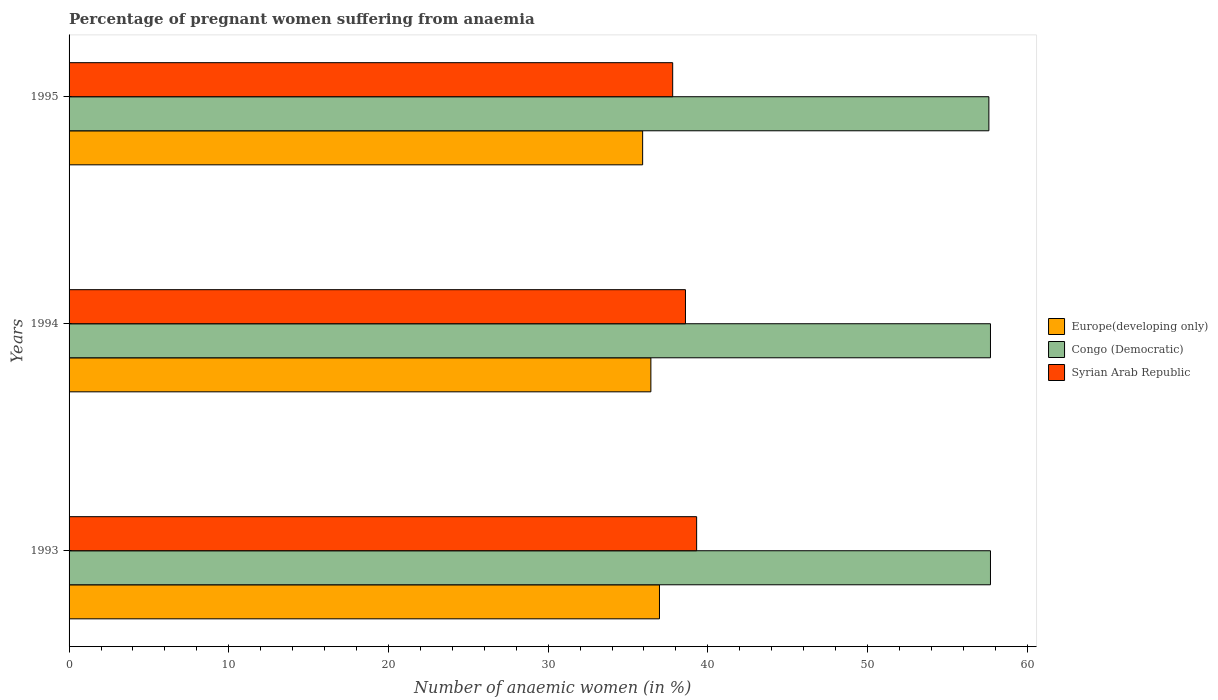What is the number of anaemic women in Congo (Democratic) in 1995?
Your answer should be compact. 57.6. Across all years, what is the maximum number of anaemic women in Syrian Arab Republic?
Provide a short and direct response. 39.3. Across all years, what is the minimum number of anaemic women in Congo (Democratic)?
Make the answer very short. 57.6. What is the total number of anaemic women in Congo (Democratic) in the graph?
Your answer should be very brief. 173. What is the difference between the number of anaemic women in Syrian Arab Republic in 1993 and that in 1995?
Provide a succinct answer. 1.5. What is the difference between the number of anaemic women in Europe(developing only) in 1993 and the number of anaemic women in Congo (Democratic) in 1995?
Keep it short and to the point. -20.63. What is the average number of anaemic women in Europe(developing only) per year?
Provide a succinct answer. 36.44. In the year 1993, what is the difference between the number of anaemic women in Congo (Democratic) and number of anaemic women in Europe(developing only)?
Ensure brevity in your answer.  20.73. What is the ratio of the number of anaemic women in Congo (Democratic) in 1993 to that in 1994?
Your answer should be compact. 1. Is the number of anaemic women in Syrian Arab Republic in 1994 less than that in 1995?
Ensure brevity in your answer.  No. What is the difference between the highest and the second highest number of anaemic women in Europe(developing only)?
Provide a short and direct response. 0.54. What is the difference between the highest and the lowest number of anaemic women in Europe(developing only)?
Your response must be concise. 1.05. Is the sum of the number of anaemic women in Congo (Democratic) in 1993 and 1994 greater than the maximum number of anaemic women in Syrian Arab Republic across all years?
Your answer should be very brief. Yes. What does the 1st bar from the top in 1995 represents?
Offer a very short reply. Syrian Arab Republic. What does the 1st bar from the bottom in 1995 represents?
Provide a short and direct response. Europe(developing only). Is it the case that in every year, the sum of the number of anaemic women in Europe(developing only) and number of anaemic women in Congo (Democratic) is greater than the number of anaemic women in Syrian Arab Republic?
Provide a succinct answer. Yes. What is the difference between two consecutive major ticks on the X-axis?
Provide a short and direct response. 10. Are the values on the major ticks of X-axis written in scientific E-notation?
Make the answer very short. No. Does the graph contain any zero values?
Provide a short and direct response. No. How many legend labels are there?
Give a very brief answer. 3. How are the legend labels stacked?
Offer a very short reply. Vertical. What is the title of the graph?
Keep it short and to the point. Percentage of pregnant women suffering from anaemia. Does "Ecuador" appear as one of the legend labels in the graph?
Make the answer very short. No. What is the label or title of the X-axis?
Make the answer very short. Number of anaemic women (in %). What is the label or title of the Y-axis?
Your answer should be compact. Years. What is the Number of anaemic women (in %) of Europe(developing only) in 1993?
Offer a very short reply. 36.97. What is the Number of anaemic women (in %) in Congo (Democratic) in 1993?
Provide a short and direct response. 57.7. What is the Number of anaemic women (in %) of Syrian Arab Republic in 1993?
Offer a very short reply. 39.3. What is the Number of anaemic women (in %) in Europe(developing only) in 1994?
Your answer should be very brief. 36.43. What is the Number of anaemic women (in %) of Congo (Democratic) in 1994?
Give a very brief answer. 57.7. What is the Number of anaemic women (in %) of Syrian Arab Republic in 1994?
Offer a very short reply. 38.6. What is the Number of anaemic women (in %) in Europe(developing only) in 1995?
Make the answer very short. 35.92. What is the Number of anaemic women (in %) of Congo (Democratic) in 1995?
Offer a very short reply. 57.6. What is the Number of anaemic women (in %) in Syrian Arab Republic in 1995?
Your answer should be very brief. 37.8. Across all years, what is the maximum Number of anaemic women (in %) in Europe(developing only)?
Keep it short and to the point. 36.97. Across all years, what is the maximum Number of anaemic women (in %) in Congo (Democratic)?
Give a very brief answer. 57.7. Across all years, what is the maximum Number of anaemic women (in %) in Syrian Arab Republic?
Your answer should be compact. 39.3. Across all years, what is the minimum Number of anaemic women (in %) of Europe(developing only)?
Provide a short and direct response. 35.92. Across all years, what is the minimum Number of anaemic women (in %) in Congo (Democratic)?
Provide a succinct answer. 57.6. Across all years, what is the minimum Number of anaemic women (in %) in Syrian Arab Republic?
Your answer should be compact. 37.8. What is the total Number of anaemic women (in %) in Europe(developing only) in the graph?
Offer a terse response. 109.32. What is the total Number of anaemic women (in %) in Congo (Democratic) in the graph?
Your response must be concise. 173. What is the total Number of anaemic women (in %) of Syrian Arab Republic in the graph?
Provide a short and direct response. 115.7. What is the difference between the Number of anaemic women (in %) in Europe(developing only) in 1993 and that in 1994?
Your answer should be very brief. 0.54. What is the difference between the Number of anaemic women (in %) in Europe(developing only) in 1993 and that in 1995?
Offer a terse response. 1.05. What is the difference between the Number of anaemic women (in %) of Congo (Democratic) in 1993 and that in 1995?
Offer a terse response. 0.1. What is the difference between the Number of anaemic women (in %) in Syrian Arab Republic in 1993 and that in 1995?
Offer a very short reply. 1.5. What is the difference between the Number of anaemic women (in %) of Europe(developing only) in 1994 and that in 1995?
Keep it short and to the point. 0.52. What is the difference between the Number of anaemic women (in %) in Europe(developing only) in 1993 and the Number of anaemic women (in %) in Congo (Democratic) in 1994?
Ensure brevity in your answer.  -20.73. What is the difference between the Number of anaemic women (in %) of Europe(developing only) in 1993 and the Number of anaemic women (in %) of Syrian Arab Republic in 1994?
Offer a terse response. -1.63. What is the difference between the Number of anaemic women (in %) in Congo (Democratic) in 1993 and the Number of anaemic women (in %) in Syrian Arab Republic in 1994?
Provide a short and direct response. 19.1. What is the difference between the Number of anaemic women (in %) of Europe(developing only) in 1993 and the Number of anaemic women (in %) of Congo (Democratic) in 1995?
Keep it short and to the point. -20.63. What is the difference between the Number of anaemic women (in %) in Europe(developing only) in 1993 and the Number of anaemic women (in %) in Syrian Arab Republic in 1995?
Your response must be concise. -0.83. What is the difference between the Number of anaemic women (in %) in Congo (Democratic) in 1993 and the Number of anaemic women (in %) in Syrian Arab Republic in 1995?
Your response must be concise. 19.9. What is the difference between the Number of anaemic women (in %) in Europe(developing only) in 1994 and the Number of anaemic women (in %) in Congo (Democratic) in 1995?
Keep it short and to the point. -21.17. What is the difference between the Number of anaemic women (in %) of Europe(developing only) in 1994 and the Number of anaemic women (in %) of Syrian Arab Republic in 1995?
Give a very brief answer. -1.37. What is the difference between the Number of anaemic women (in %) in Congo (Democratic) in 1994 and the Number of anaemic women (in %) in Syrian Arab Republic in 1995?
Keep it short and to the point. 19.9. What is the average Number of anaemic women (in %) in Europe(developing only) per year?
Keep it short and to the point. 36.44. What is the average Number of anaemic women (in %) in Congo (Democratic) per year?
Your response must be concise. 57.67. What is the average Number of anaemic women (in %) of Syrian Arab Republic per year?
Make the answer very short. 38.57. In the year 1993, what is the difference between the Number of anaemic women (in %) in Europe(developing only) and Number of anaemic women (in %) in Congo (Democratic)?
Make the answer very short. -20.73. In the year 1993, what is the difference between the Number of anaemic women (in %) of Europe(developing only) and Number of anaemic women (in %) of Syrian Arab Republic?
Provide a short and direct response. -2.33. In the year 1994, what is the difference between the Number of anaemic women (in %) in Europe(developing only) and Number of anaemic women (in %) in Congo (Democratic)?
Your response must be concise. -21.27. In the year 1994, what is the difference between the Number of anaemic women (in %) in Europe(developing only) and Number of anaemic women (in %) in Syrian Arab Republic?
Offer a very short reply. -2.17. In the year 1994, what is the difference between the Number of anaemic women (in %) in Congo (Democratic) and Number of anaemic women (in %) in Syrian Arab Republic?
Keep it short and to the point. 19.1. In the year 1995, what is the difference between the Number of anaemic women (in %) in Europe(developing only) and Number of anaemic women (in %) in Congo (Democratic)?
Provide a succinct answer. -21.68. In the year 1995, what is the difference between the Number of anaemic women (in %) in Europe(developing only) and Number of anaemic women (in %) in Syrian Arab Republic?
Offer a terse response. -1.88. In the year 1995, what is the difference between the Number of anaemic women (in %) of Congo (Democratic) and Number of anaemic women (in %) of Syrian Arab Republic?
Offer a very short reply. 19.8. What is the ratio of the Number of anaemic women (in %) in Europe(developing only) in 1993 to that in 1994?
Give a very brief answer. 1.01. What is the ratio of the Number of anaemic women (in %) in Syrian Arab Republic in 1993 to that in 1994?
Ensure brevity in your answer.  1.02. What is the ratio of the Number of anaemic women (in %) in Europe(developing only) in 1993 to that in 1995?
Provide a short and direct response. 1.03. What is the ratio of the Number of anaemic women (in %) of Congo (Democratic) in 1993 to that in 1995?
Provide a short and direct response. 1. What is the ratio of the Number of anaemic women (in %) in Syrian Arab Republic in 1993 to that in 1995?
Keep it short and to the point. 1.04. What is the ratio of the Number of anaemic women (in %) in Europe(developing only) in 1994 to that in 1995?
Give a very brief answer. 1.01. What is the ratio of the Number of anaemic women (in %) in Congo (Democratic) in 1994 to that in 1995?
Ensure brevity in your answer.  1. What is the ratio of the Number of anaemic women (in %) in Syrian Arab Republic in 1994 to that in 1995?
Offer a terse response. 1.02. What is the difference between the highest and the second highest Number of anaemic women (in %) of Europe(developing only)?
Keep it short and to the point. 0.54. What is the difference between the highest and the lowest Number of anaemic women (in %) of Europe(developing only)?
Your response must be concise. 1.05. What is the difference between the highest and the lowest Number of anaemic women (in %) of Congo (Democratic)?
Your answer should be very brief. 0.1. 